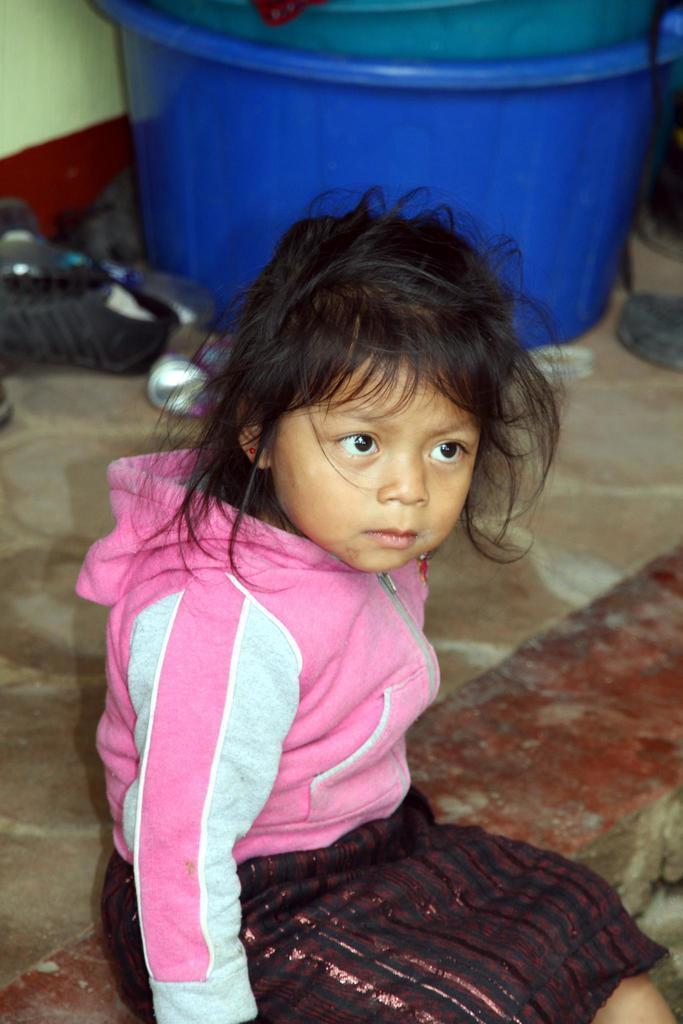What is the girl in the image doing? The girl is sitting on the floor in the image. What can be seen in the image besides the girl? There are plastic tubs and objects on the floor in the image. How many yaks are present in the image? There are no yaks present in the image. Are the girl's sisters also sitting on the floor in the image? The provided facts do not mention any sisters, so we cannot determine if they are present in the image. 